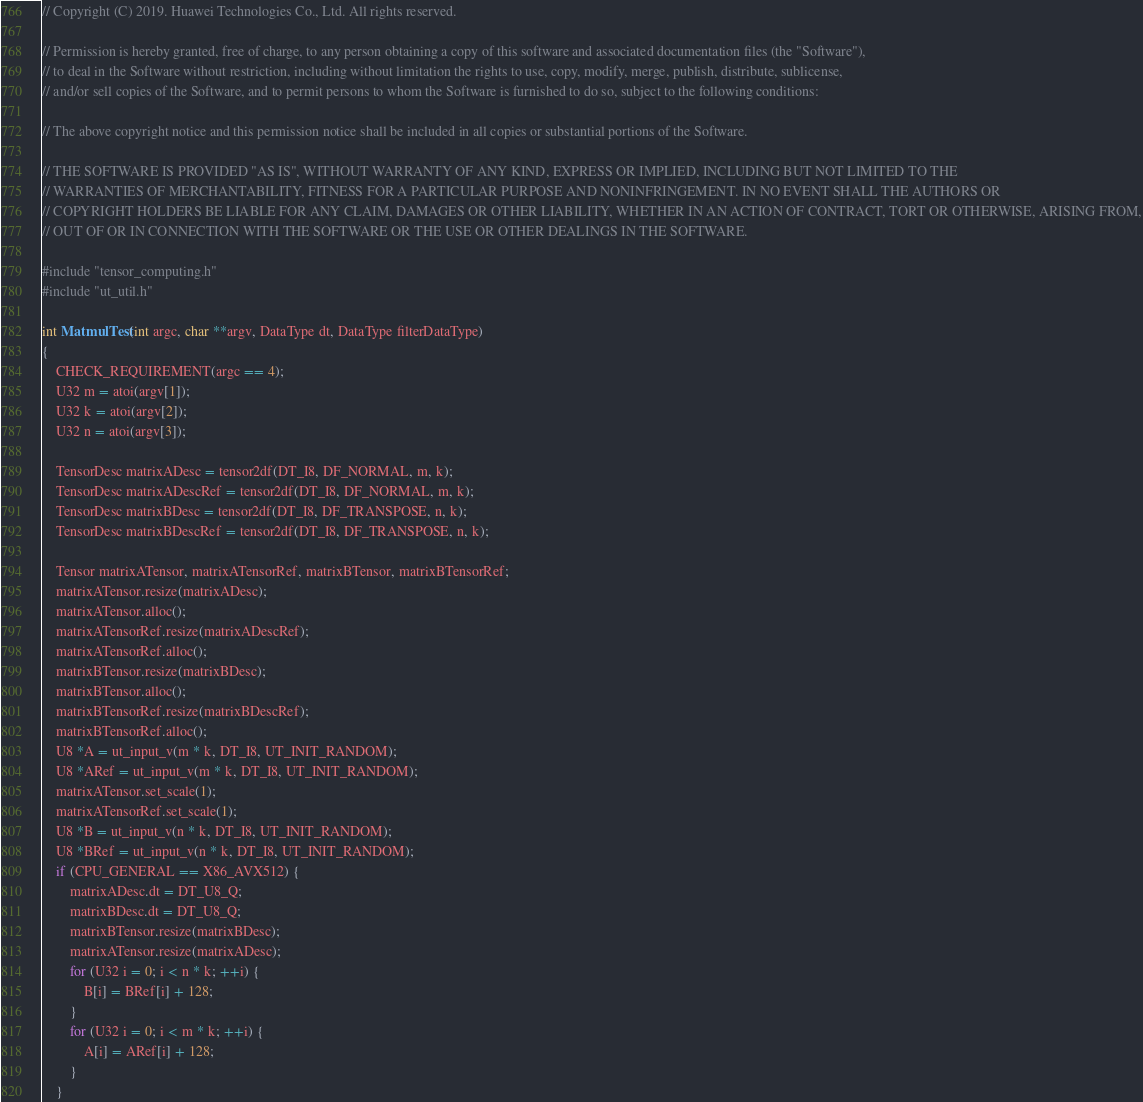<code> <loc_0><loc_0><loc_500><loc_500><_C++_>// Copyright (C) 2019. Huawei Technologies Co., Ltd. All rights reserved.

// Permission is hereby granted, free of charge, to any person obtaining a copy of this software and associated documentation files (the "Software"),
// to deal in the Software without restriction, including without limitation the rights to use, copy, modify, merge, publish, distribute, sublicense,
// and/or sell copies of the Software, and to permit persons to whom the Software is furnished to do so, subject to the following conditions:

// The above copyright notice and this permission notice shall be included in all copies or substantial portions of the Software.

// THE SOFTWARE IS PROVIDED "AS IS", WITHOUT WARRANTY OF ANY KIND, EXPRESS OR IMPLIED, INCLUDING BUT NOT LIMITED TO THE
// WARRANTIES OF MERCHANTABILITY, FITNESS FOR A PARTICULAR PURPOSE AND NONINFRINGEMENT. IN NO EVENT SHALL THE AUTHORS OR
// COPYRIGHT HOLDERS BE LIABLE FOR ANY CLAIM, DAMAGES OR OTHER LIABILITY, WHETHER IN AN ACTION OF CONTRACT, TORT OR OTHERWISE, ARISING FROM,
// OUT OF OR IN CONNECTION WITH THE SOFTWARE OR THE USE OR OTHER DEALINGS IN THE SOFTWARE.

#include "tensor_computing.h"
#include "ut_util.h"

int MatmulTest(int argc, char **argv, DataType dt, DataType filterDataType)
{
    CHECK_REQUIREMENT(argc == 4);
    U32 m = atoi(argv[1]);
    U32 k = atoi(argv[2]);
    U32 n = atoi(argv[3]);

    TensorDesc matrixADesc = tensor2df(DT_I8, DF_NORMAL, m, k);
    TensorDesc matrixADescRef = tensor2df(DT_I8, DF_NORMAL, m, k);
    TensorDesc matrixBDesc = tensor2df(DT_I8, DF_TRANSPOSE, n, k);
    TensorDesc matrixBDescRef = tensor2df(DT_I8, DF_TRANSPOSE, n, k);

    Tensor matrixATensor, matrixATensorRef, matrixBTensor, matrixBTensorRef;
    matrixATensor.resize(matrixADesc);
    matrixATensor.alloc();
    matrixATensorRef.resize(matrixADescRef);
    matrixATensorRef.alloc();
    matrixBTensor.resize(matrixBDesc);
    matrixBTensor.alloc();
    matrixBTensorRef.resize(matrixBDescRef);
    matrixBTensorRef.alloc();
    U8 *A = ut_input_v(m * k, DT_I8, UT_INIT_RANDOM);
    U8 *ARef = ut_input_v(m * k, DT_I8, UT_INIT_RANDOM);
    matrixATensor.set_scale(1);
    matrixATensorRef.set_scale(1);
    U8 *B = ut_input_v(n * k, DT_I8, UT_INIT_RANDOM);
    U8 *BRef = ut_input_v(n * k, DT_I8, UT_INIT_RANDOM);
    if (CPU_GENERAL == X86_AVX512) {
        matrixADesc.dt = DT_U8_Q;
        matrixBDesc.dt = DT_U8_Q;
        matrixBTensor.resize(matrixBDesc);
        matrixATensor.resize(matrixADesc);
        for (U32 i = 0; i < n * k; ++i) {
            B[i] = BRef[i] + 128;
        }
        for (U32 i = 0; i < m * k; ++i) {
            A[i] = ARef[i] + 128;
        }
    }</code> 